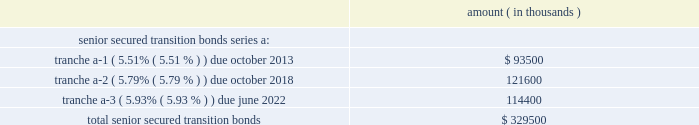Entergy corporation and subsidiaries notes to financial statements in november 2000 , entergy's non-utility nuclear business purchased the fitzpatrick and indian point 3 power plants in a seller-financed transaction .
Entergy issued notes to nypa with seven annual installments of approximately $ 108 million commencing one year from the date of the closing , and eight annual installments of $ 20 million commencing eight years from the date of the closing .
These notes do not have a stated interest rate , but have an implicit interest rate of 4.8% ( 4.8 % ) .
In accordance with the purchase agreement with nypa , the purchase of indian point 2 in 2001 resulted in entergy's non-utility nuclear business becoming liable to nypa for an additional $ 10 million per year for 10 years , beginning in september 2003 .
This liability was recorded upon the purchase of indian point 2 in september 2001 , and is included in the note payable to nypa balance above .
In july 2003 , a payment of $ 102 million was made prior to maturity on the note payable to nypa .
Under a provision in a letter of credit supporting these notes , if certain of the utility operating companies or system energy were to default on other indebtedness , entergy could be required to post collateral to support the letter of credit .
Covenants in the entergy corporation notes require it to maintain a consolidated debt ratio of 65% ( 65 % ) or less of its total capitalization .
If entergy's debt ratio exceeds this limit , or if entergy corporation or certain of the utility operating companies default on other indebtedness or are in bankruptcy or insolvency proceedings , an acceleration of the notes' maturity dates may occur .
Entergy gulf states louisiana , entergy louisiana , entergy mississippi , entergy texas , and system energy have received ferc long-term financing orders authorizing long-term securities issuances .
Entergy arkansas has received an apsc long-term financing order authorizing long-term securities issuances .
The long-term securities issuances of entergy new orleans are limited to amounts authorized by the city council , and the current authorization extends through august 2010 .
Capital funds agreement pursuant to an agreement with certain creditors , entergy corporation has agreed to supply system energy with sufficient capital to : maintain system energy's equity capital at a minimum of 35% ( 35 % ) of its total capitalization ( excluding short- term debt ) ; permit the continued commercial operation of grand gulf ; pay in full all system energy indebtedness for borrowed money when due ; and enable system energy to make payments on specific system energy debt , under supplements to the agreement assigning system energy's rights in the agreement as security for the specific debt .
Entergy texas securitization bonds - hurricane rita in april 2007 , the puct issued a financing order authorizing the issuance of securitization bonds to recover $ 353 million of entergy texas' hurricane rita reconstruction costs and up to $ 6 million of transaction costs , offset by $ 32 million of related deferred income tax benefits .
In june 2007 , entergy gulf states reconstruction funding i , llc , a company wholly-owned and consolidated by entergy texas , issued $ 329.5 million of senior secured transition bonds ( securitization bonds ) , as follows : amount ( in thousands ) .

What portion of the securitization bonds issued by entergy gulf states reconstruction funding has a maturity date in 2022? 
Computations: (114400 / 329500)
Answer: 0.34719. 